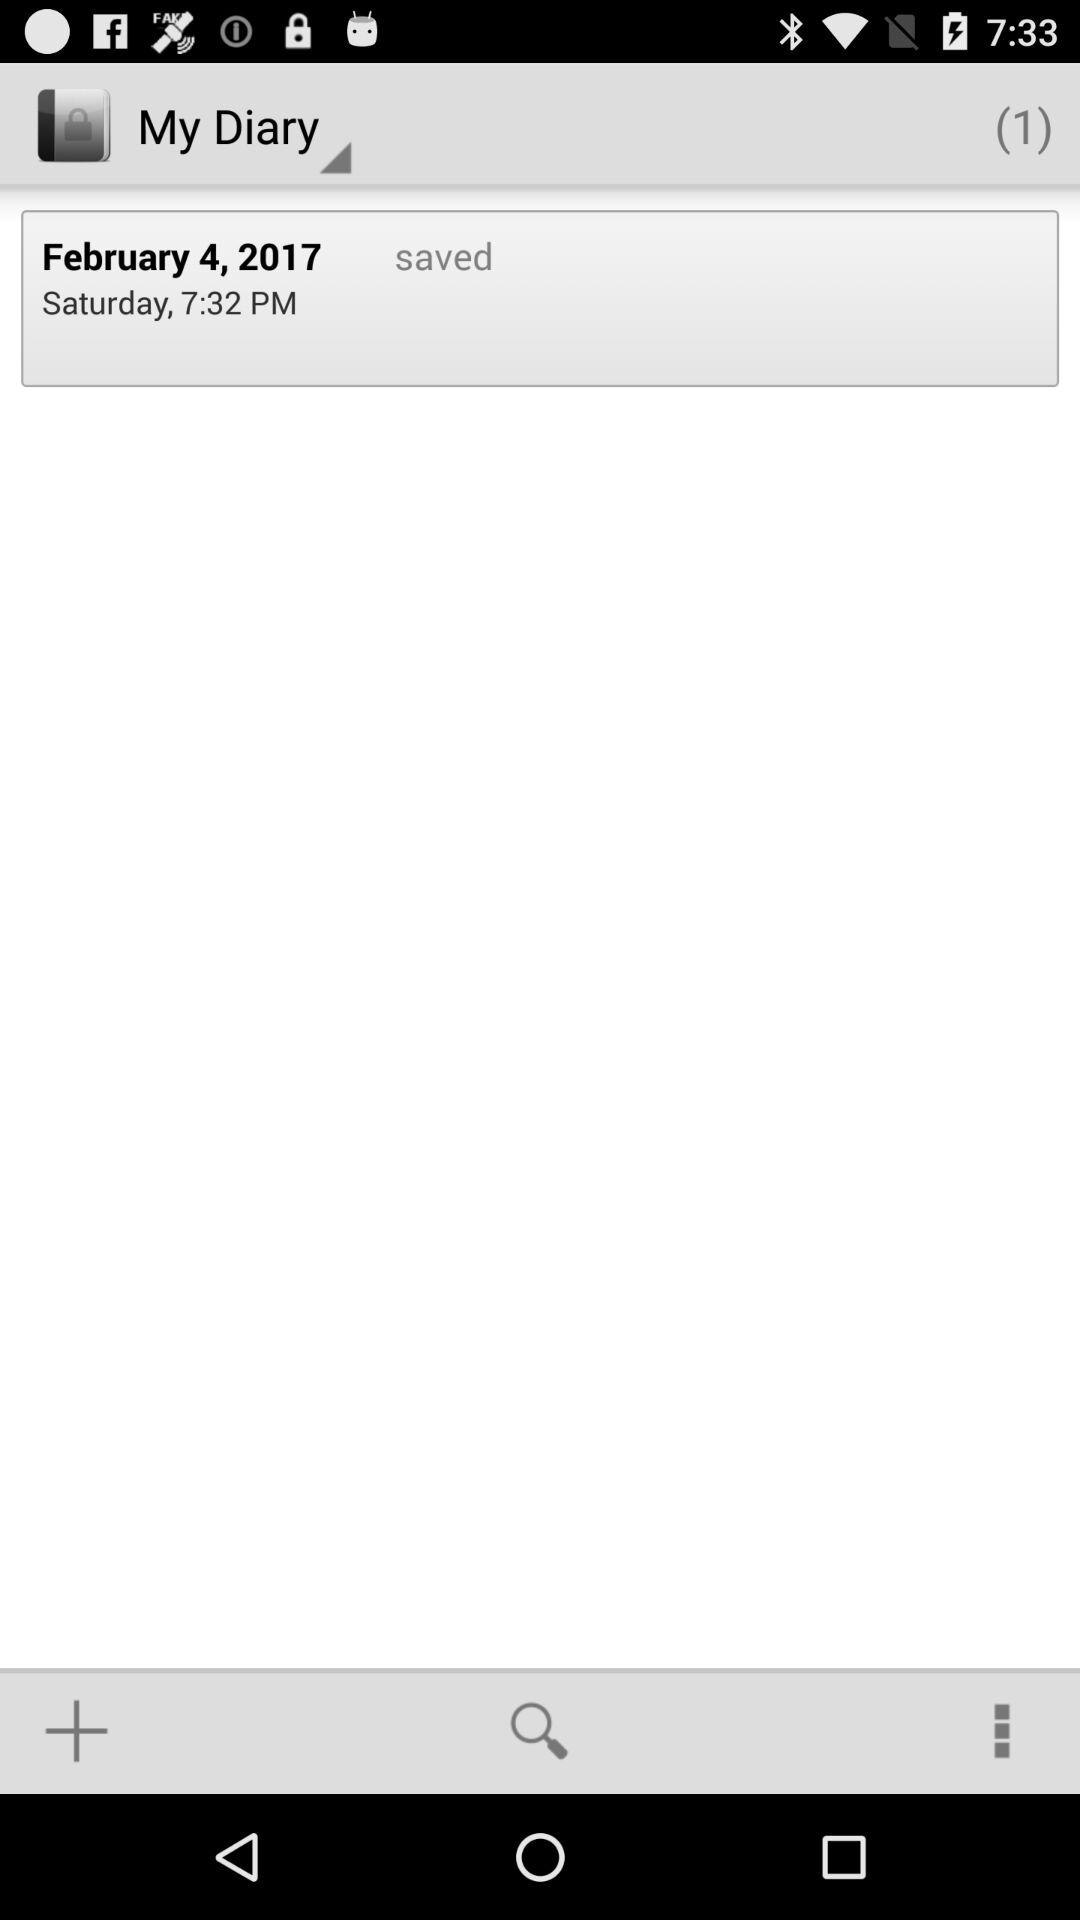What is the time? The time is 7:32 PM. 